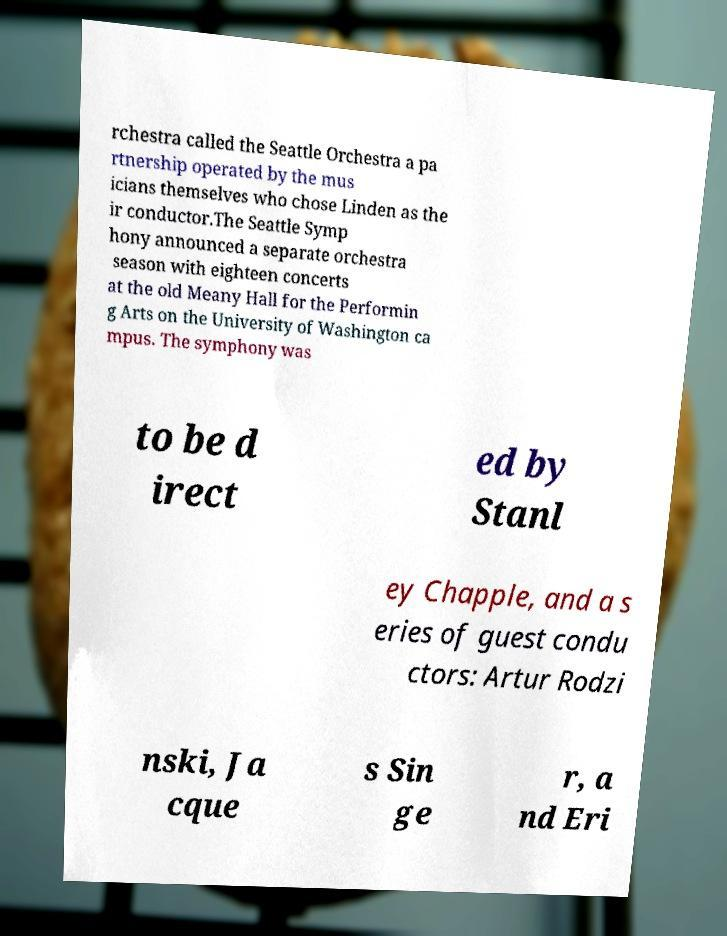Could you extract and type out the text from this image? rchestra called the Seattle Orchestra a pa rtnership operated by the mus icians themselves who chose Linden as the ir conductor.The Seattle Symp hony announced a separate orchestra season with eighteen concerts at the old Meany Hall for the Performin g Arts on the University of Washington ca mpus. The symphony was to be d irect ed by Stanl ey Chapple, and a s eries of guest condu ctors: Artur Rodzi nski, Ja cque s Sin ge r, a nd Eri 